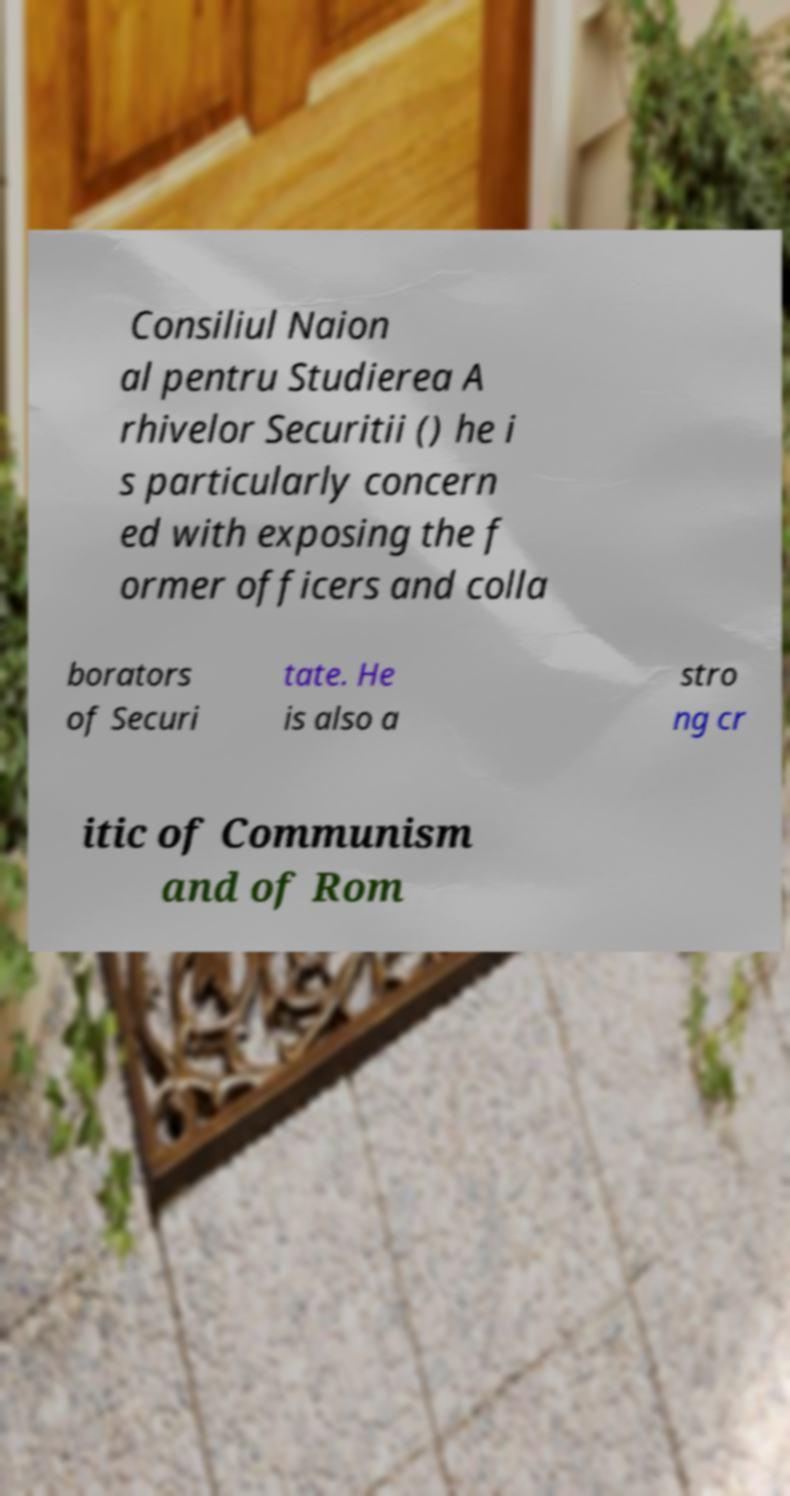Could you assist in decoding the text presented in this image and type it out clearly? Consiliul Naion al pentru Studierea A rhivelor Securitii () he i s particularly concern ed with exposing the f ormer officers and colla borators of Securi tate. He is also a stro ng cr itic of Communism and of Rom 